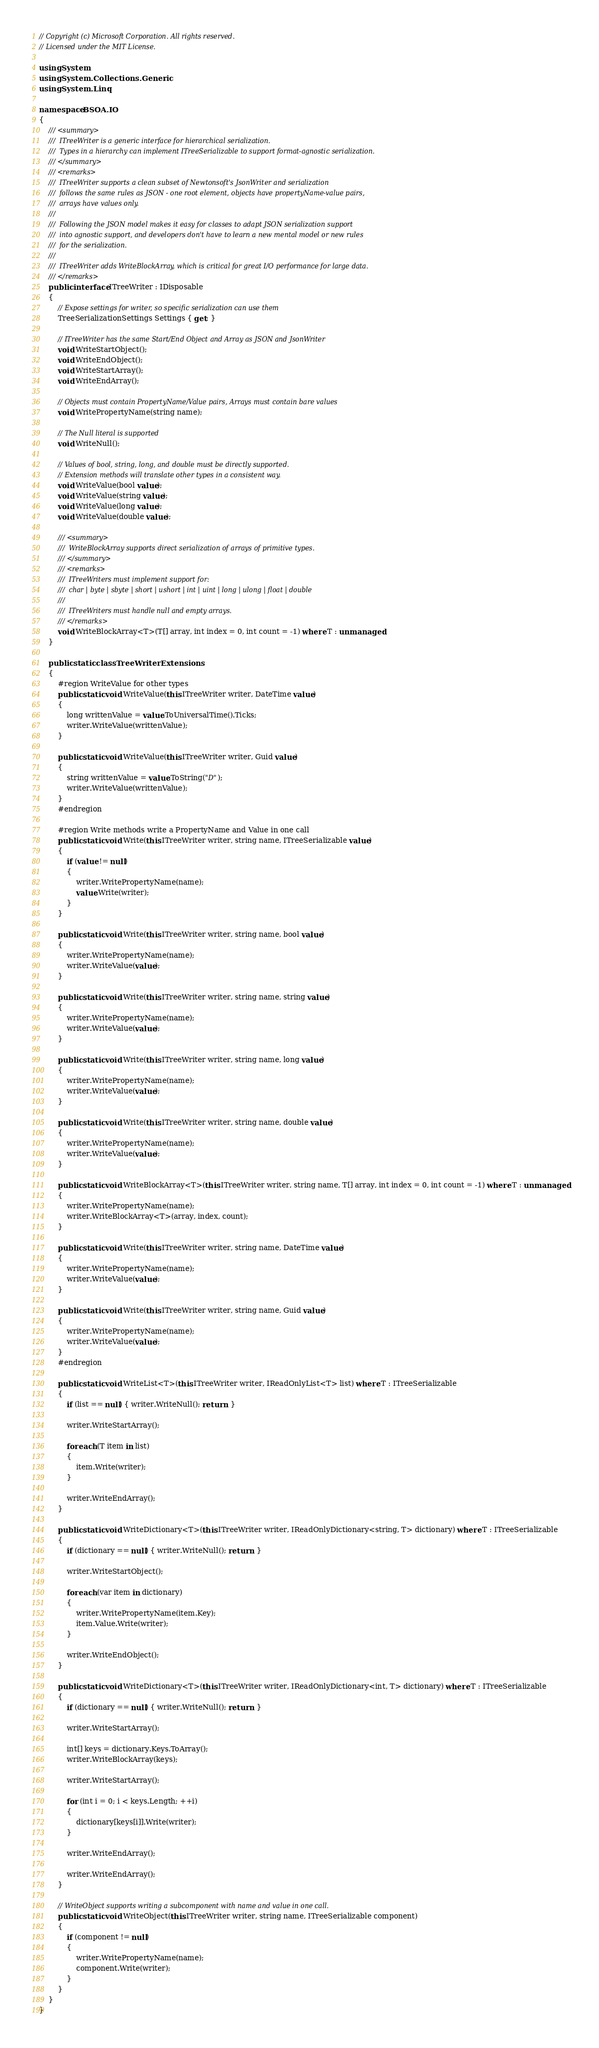Convert code to text. <code><loc_0><loc_0><loc_500><loc_500><_C#_>// Copyright (c) Microsoft Corporation. All rights reserved.
// Licensed under the MIT License.

using System;
using System.Collections.Generic;
using System.Linq;

namespace BSOA.IO
{
    /// <summary>
    ///  ITreeWriter is a generic interface for hierarchical serialization.
    ///  Types in a hierarchy can implement ITreeSerializable to support format-agnostic serialization.
    /// </summary>
    /// <remarks>
    ///  ITreeWriter supports a clean subset of Newtonsoft's JsonWriter and serialization
    ///  follows the same rules as JSON - one root element, objects have propertyName-value pairs,
    ///  arrays have values only.
    ///  
    ///  Following the JSON model makes it easy for classes to adapt JSON serialization support
    ///  into agnostic support, and developers don't have to learn a new mental model or new rules
    ///  for the serialization.
    ///  
    ///  ITreeWriter adds WriteBlockArray, which is critical for great I/O performance for large data.
    /// </remarks>
    public interface ITreeWriter : IDisposable
    {
        // Expose settings for writer, so specific serialization can use them
        TreeSerializationSettings Settings { get; }

        // ITreeWriter has the same Start/End Object and Array as JSON and JsonWriter
        void WriteStartObject();
        void WriteEndObject();
        void WriteStartArray();
        void WriteEndArray();

        // Objects must contain PropertyName/Value pairs, Arrays must contain bare values
        void WritePropertyName(string name);

        // The Null literal is supported
        void WriteNull();

        // Values of bool, string, long, and double must be directly supported.
        // Extension methods will translate other types in a consistent way.
        void WriteValue(bool value);
        void WriteValue(string value);
        void WriteValue(long value);
        void WriteValue(double value);

        /// <summary>
        ///  WriteBlockArray supports direct serialization of arrays of primitive types.
        /// </summary>
        /// <remarks>
        ///  ITreeWriters must implement support for:
        ///  char | byte | sbyte | short | ushort | int | uint | long | ulong | float | double
        ///  
        ///  ITreeWriters must handle null and empty arrays.
        /// </remarks>
        void WriteBlockArray<T>(T[] array, int index = 0, int count = -1) where T : unmanaged;
    }

    public static class TreeWriterExtensions
    {
        #region WriteValue for other types
        public static void WriteValue(this ITreeWriter writer, DateTime value)
        {
            long writtenValue = value.ToUniversalTime().Ticks;
            writer.WriteValue(writtenValue);
        }

        public static void WriteValue(this ITreeWriter writer, Guid value)
        {
            string writtenValue = value.ToString("D");
            writer.WriteValue(writtenValue);
        }
        #endregion

        #region Write methods write a PropertyName and Value in one call
        public static void Write(this ITreeWriter writer, string name, ITreeSerializable value)
        {
            if (value != null)
            {
                writer.WritePropertyName(name);
                value.Write(writer);
            }
        }

        public static void Write(this ITreeWriter writer, string name, bool value)
        {
            writer.WritePropertyName(name);
            writer.WriteValue(value);
        }

        public static void Write(this ITreeWriter writer, string name, string value)
        {
            writer.WritePropertyName(name);
            writer.WriteValue(value);
        }

        public static void Write(this ITreeWriter writer, string name, long value)
        {
            writer.WritePropertyName(name);
            writer.WriteValue(value);
        }

        public static void Write(this ITreeWriter writer, string name, double value)
        {
            writer.WritePropertyName(name);
            writer.WriteValue(value);
        }

        public static void WriteBlockArray<T>(this ITreeWriter writer, string name, T[] array, int index = 0, int count = -1) where T : unmanaged
        {
            writer.WritePropertyName(name);
            writer.WriteBlockArray<T>(array, index, count);
        }

        public static void Write(this ITreeWriter writer, string name, DateTime value)
        {
            writer.WritePropertyName(name);
            writer.WriteValue(value);
        }

        public static void Write(this ITreeWriter writer, string name, Guid value)
        {
            writer.WritePropertyName(name);
            writer.WriteValue(value);
        }
        #endregion

        public static void WriteList<T>(this ITreeWriter writer, IReadOnlyList<T> list) where T : ITreeSerializable
        {
            if (list == null) { writer.WriteNull(); return; }

            writer.WriteStartArray();

            foreach (T item in list)
            {
                item.Write(writer);
            }

            writer.WriteEndArray();
        }

        public static void WriteDictionary<T>(this ITreeWriter writer, IReadOnlyDictionary<string, T> dictionary) where T : ITreeSerializable
        {
            if (dictionary == null) { writer.WriteNull(); return; }

            writer.WriteStartObject();

            foreach (var item in dictionary)
            {
                writer.WritePropertyName(item.Key);
                item.Value.Write(writer);
            }

            writer.WriteEndObject();
        }

        public static void WriteDictionary<T>(this ITreeWriter writer, IReadOnlyDictionary<int, T> dictionary) where T : ITreeSerializable
        {
            if (dictionary == null) { writer.WriteNull(); return; }

            writer.WriteStartArray();

            int[] keys = dictionary.Keys.ToArray();
            writer.WriteBlockArray(keys);

            writer.WriteStartArray();

            for (int i = 0; i < keys.Length; ++i)
            {
                dictionary[keys[i]].Write(writer);
            }

            writer.WriteEndArray();

            writer.WriteEndArray();
        }

        // WriteObject supports writing a subcomponent with name and value in one call.
        public static void WriteObject(this ITreeWriter writer, string name, ITreeSerializable component)
        {
            if (component != null)
            {
                writer.WritePropertyName(name);
                component.Write(writer);
            }
        }
    }
}
</code> 